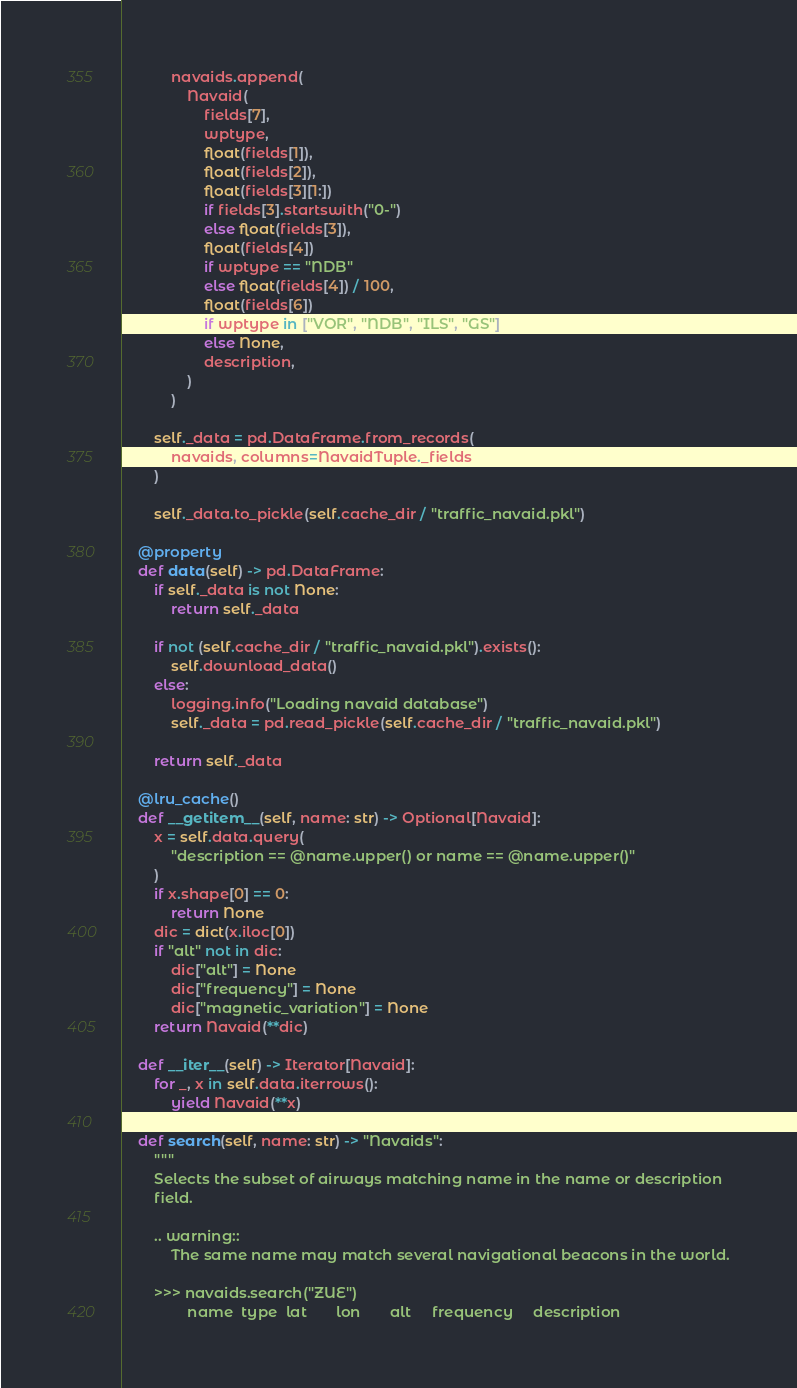Convert code to text. <code><loc_0><loc_0><loc_500><loc_500><_Python_>            navaids.append(
                Navaid(
                    fields[7],
                    wptype,
                    float(fields[1]),
                    float(fields[2]),
                    float(fields[3][1:])
                    if fields[3].startswith("0-")
                    else float(fields[3]),
                    float(fields[4])
                    if wptype == "NDB"
                    else float(fields[4]) / 100,
                    float(fields[6])
                    if wptype in ["VOR", "NDB", "ILS", "GS"]
                    else None,
                    description,
                )
            )

        self._data = pd.DataFrame.from_records(
            navaids, columns=NavaidTuple._fields
        )

        self._data.to_pickle(self.cache_dir / "traffic_navaid.pkl")

    @property
    def data(self) -> pd.DataFrame:
        if self._data is not None:
            return self._data

        if not (self.cache_dir / "traffic_navaid.pkl").exists():
            self.download_data()
        else:
            logging.info("Loading navaid database")
            self._data = pd.read_pickle(self.cache_dir / "traffic_navaid.pkl")

        return self._data

    @lru_cache()
    def __getitem__(self, name: str) -> Optional[Navaid]:
        x = self.data.query(
            "description == @name.upper() or name == @name.upper()"
        )
        if x.shape[0] == 0:
            return None
        dic = dict(x.iloc[0])
        if "alt" not in dic:
            dic["alt"] = None
            dic["frequency"] = None
            dic["magnetic_variation"] = None
        return Navaid(**dic)

    def __iter__(self) -> Iterator[Navaid]:
        for _, x in self.data.iterrows():
            yield Navaid(**x)

    def search(self, name: str) -> "Navaids":
        """
        Selects the subset of airways matching name in the name or description
        field.

        .. warning::
            The same name may match several navigational beacons in the world.

        >>> navaids.search("ZUE")
                name  type  lat       lon       alt     frequency     description</code> 